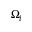Convert formula to latex. <formula><loc_0><loc_0><loc_500><loc_500>\Omega _ { l }</formula> 